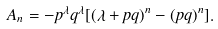<formula> <loc_0><loc_0><loc_500><loc_500>A _ { n } = - p ^ { \lambda } q ^ { \lambda } [ ( \lambda + p q ) ^ { n } - ( p q ) ^ { n } ] .</formula> 